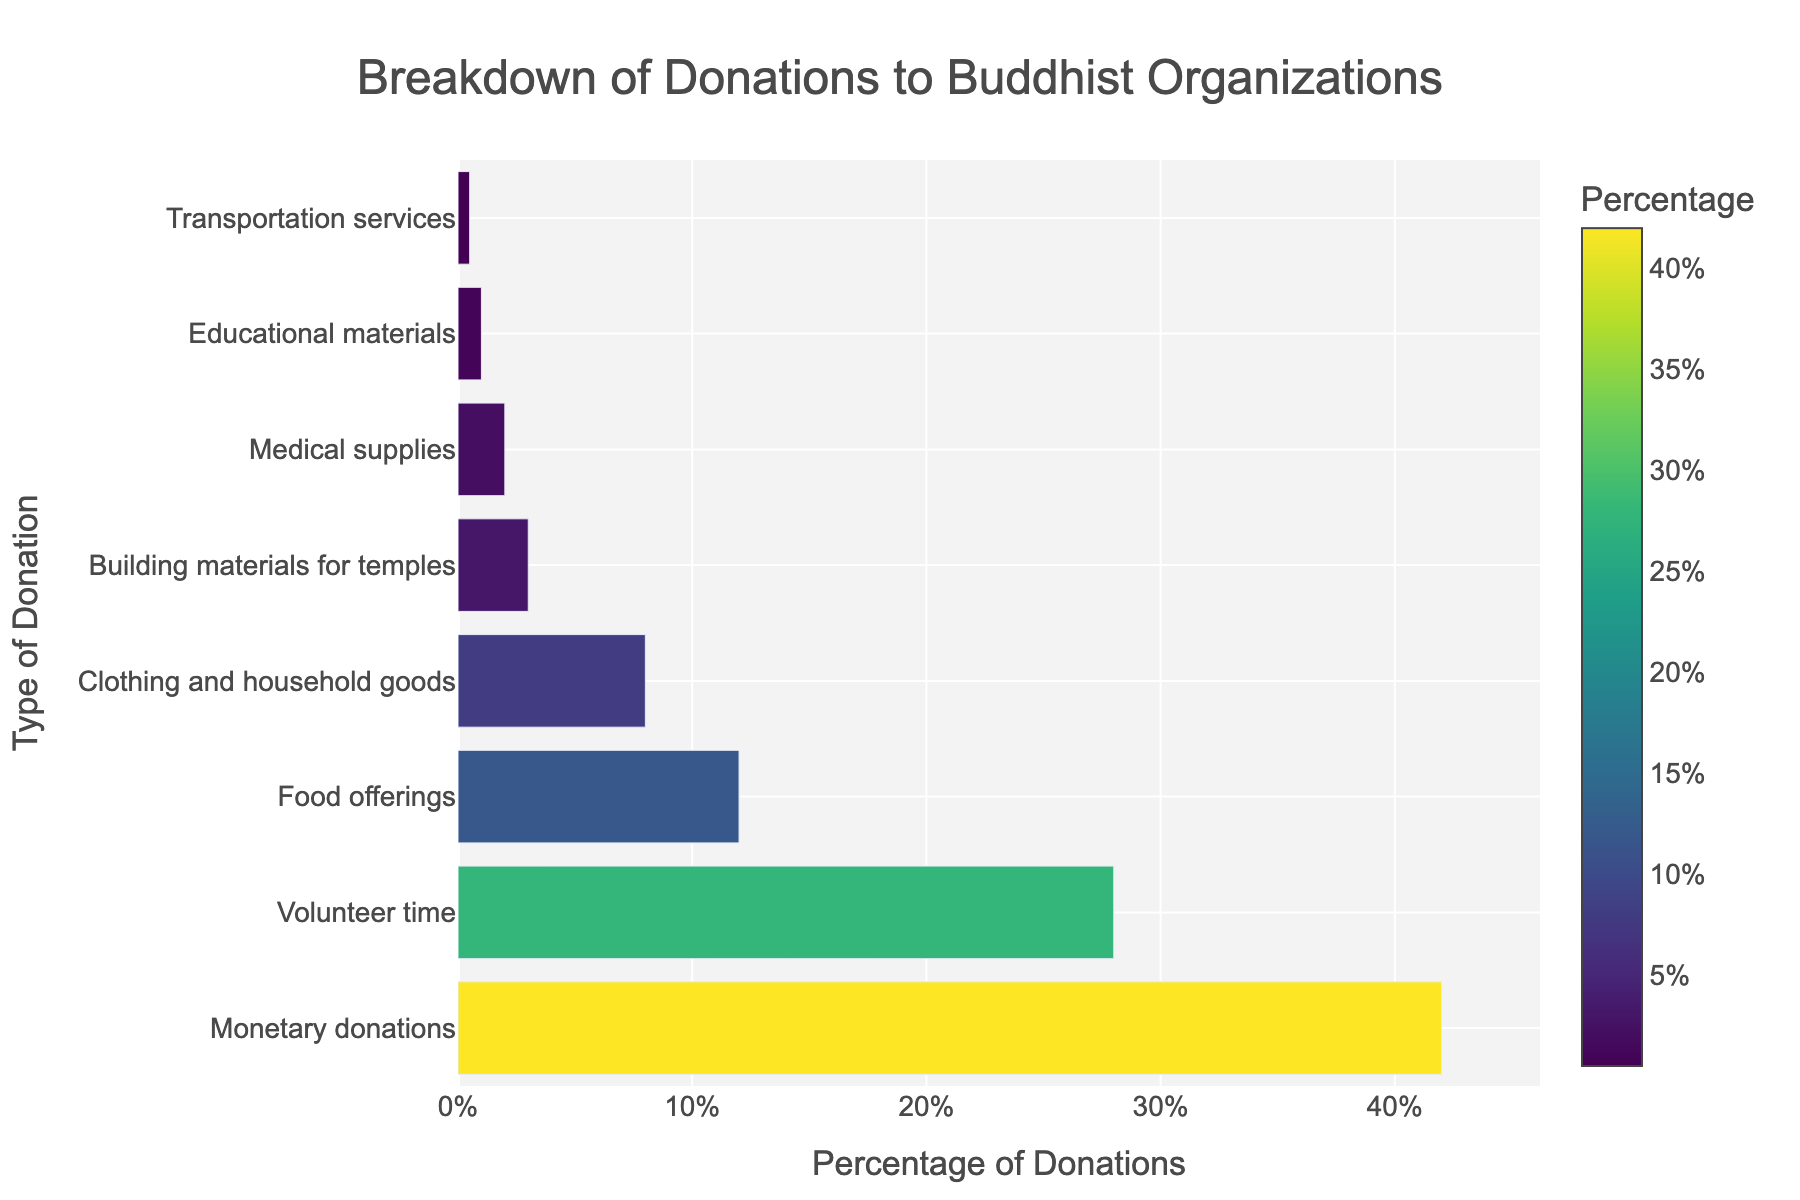What is the most common type of donation? The most common type of donation is represented by the longest bar in the bar chart. By looking at the bar chart, the bar labeled "Monetary donations" has the highest percentage value.
Answer: Monetary donations What is the combined percentage of food offerings, clothing and household goods, and building materials for temples? Add the percentages for food offerings (12%), clothing and household goods (8%), and building materials for temples (3%). 12% + 8% + 3% = 23%.
Answer: 23% How much greater is the percentage of monetary donations compared to volunteer time? Subtract the percentage of volunteer time (28%) from the percentage of monetary donations (42%). 42% - 28% = 14%.
Answer: 14% Which donation type contributes the least percentage? The bar chart shows the shortest bar represents the least percentage, which is labeled "Transportation services" with 0.5%.
Answer: Transportation services What is the difference between the percentages of food offerings and medical supplies? Subtract the percentage of medical supplies (2%) from food offerings (12%). 12% - 2% = 10%.
Answer: 10% What is the total percentage of all donation types combined? Sum all percentage values: 42% + 28% + 12% + 8% + 3% + 2% + 1% + 0.5% = 96.5%.
Answer: 96.5% How do the percentages of clothing and household goods compare to building materials for temples? The percentage for clothing and household goods (8%) is greater than that for building materials for temples (3%).
Answer: Clothing and household goods contribute more than building materials for temples What donation type is represented by the second longest bar? The second longest bar in the chart corresponds to "Volunteer time" with a percentage of 28%.
Answer: Volunteer time Which donation types account for less than 5% of the total? The bars representing donation types with less than 5% are "Building materials for temples" (3%), "Medical supplies" (2%), "Educational materials" (1%), and "Transportation services" (0.5%).
Answer: Building materials for temples, Medical supplies, Educational materials, Transportation services If "Medical supplies" and "Educational materials" were grouped together, what would their combined percentage be? Add the percentages for medical supplies (2%) and educational materials (1%) to get the combined percentage: 2% + 1% = 3%.
Answer: 3% 